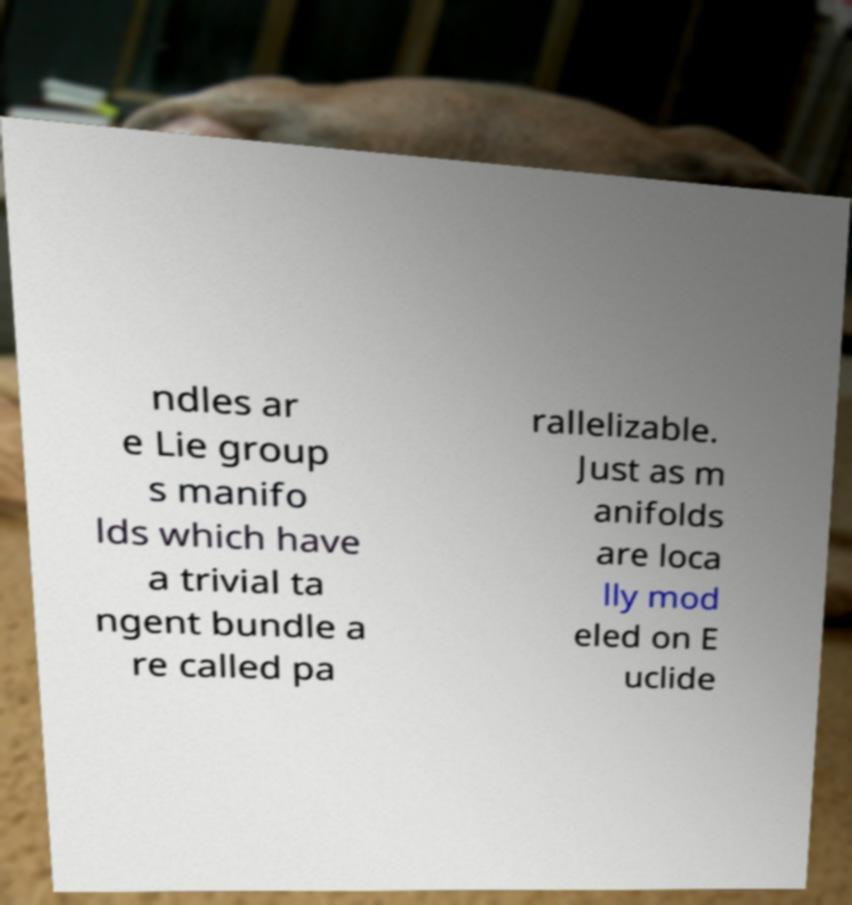Can you accurately transcribe the text from the provided image for me? ndles ar e Lie group s manifo lds which have a trivial ta ngent bundle a re called pa rallelizable. Just as m anifolds are loca lly mod eled on E uclide 